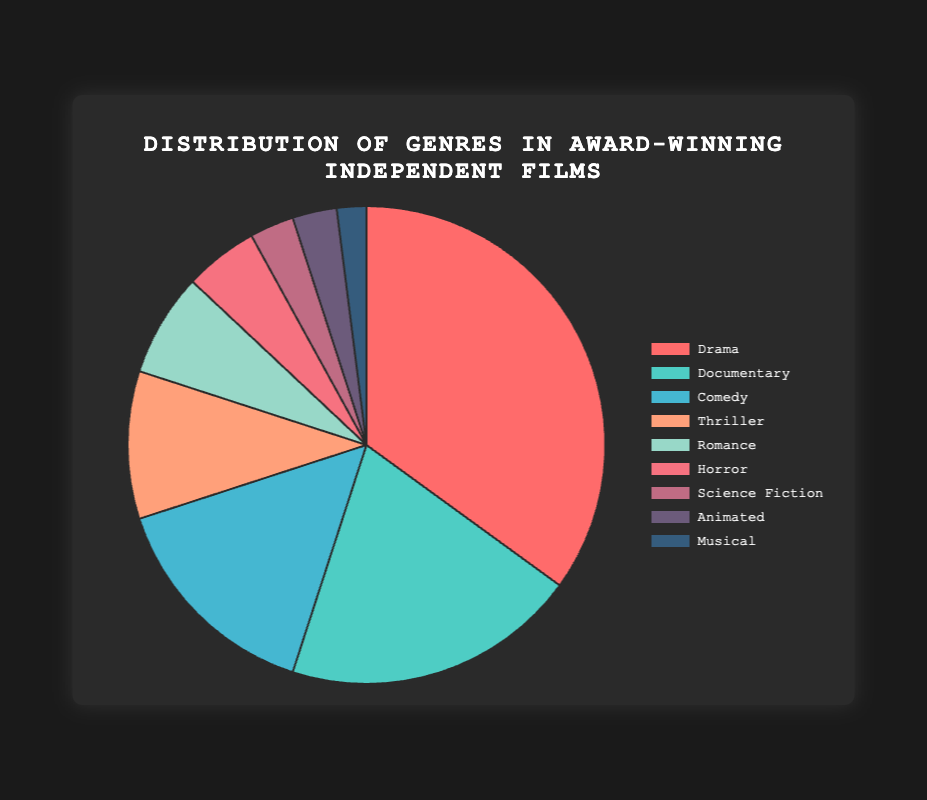Which genre has the highest percentage in award-winning independent films? The genre with the highest percentage can be determined by looking at the largest segment in the pie chart, which is labeled as Drama with 35%.
Answer: Drama Which genre has the lowest percentage in award-winning independent films? The genre with the lowest percentage can be determined by looking at the smallest segment in the pie chart, which is labeled as Musical with 2%.
Answer: Musical What is the combined percentage of Drama and Documentary genres in award-winning independent films? To find the combined percentage, sum the individual percentages of Drama (35%) and Documentary (20%). This results in 35 + 20 = 55%.
Answer: 55% How does the percentage of Comedy compare to Thriller? To compare the two, note that Comedy has 15% and Thriller has 10%. Comedy has a higher percentage than Thriller.
Answer: Comedy has a higher percentage Are there any genres that have the same percentage representation? By scanning the chart, we see that both Science Fiction and Animated genres have the same percentage of 3%.
Answer: Yes, Science Fiction and Animated What percentage of the films are either Horror or Romance? To find the combined percentage, sum the percentages of Horror (5%) and Romance (7%). This results in 5 + 7 = 12%.
Answer: 12% Which genre uses a yellowish color within the chart? By identifying the colors visually, the genre that uses a yellowish color in the chart is Romance.
Answer: Romance What's the difference in percentage between Documentary and Horror genres? To find the difference, subtract the percentage of Horror (5%) from the percentage of Documentary (20%). This results in 20 - 5 = 15%.
Answer: 15% Which genres have a percentage less than 10%? By reviewing the chart segments, the genres with less than 10% are Romance (7%), Horror (5%), Science Fiction (3%), Animated (3%), and Musical (2%).
Answer: Romance, Horror, Science Fiction, Animated, Musical What percentage of award-winning independent films are classified under genres other than Drama, Documentary, and Comedy? First, sum the percentages of Drama, Documentary, and Comedy (35% + 20% + 15% = 70%). Then, subtract this from 100% to find the percentage of other genres (100 - 70 = 30%).
Answer: 30% 